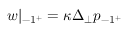<formula> <loc_0><loc_0><loc_500><loc_500>w | _ { - 1 ^ { + } } = \kappa \Delta _ { \perp } p _ { - 1 ^ { + } }</formula> 